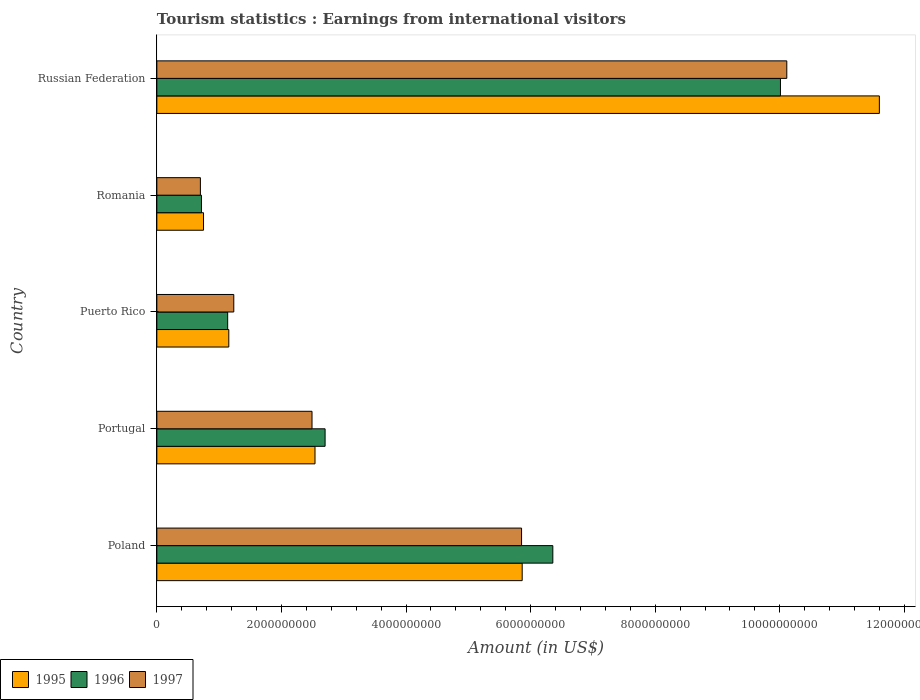How many different coloured bars are there?
Ensure brevity in your answer.  3. How many groups of bars are there?
Offer a terse response. 5. Are the number of bars on each tick of the Y-axis equal?
Ensure brevity in your answer.  Yes. How many bars are there on the 3rd tick from the top?
Provide a short and direct response. 3. How many bars are there on the 4th tick from the bottom?
Make the answer very short. 3. What is the label of the 2nd group of bars from the top?
Provide a succinct answer. Romania. In how many cases, is the number of bars for a given country not equal to the number of legend labels?
Offer a very short reply. 0. What is the earnings from international visitors in 1995 in Romania?
Provide a short and direct response. 7.49e+08. Across all countries, what is the maximum earnings from international visitors in 1996?
Keep it short and to the point. 1.00e+1. Across all countries, what is the minimum earnings from international visitors in 1995?
Provide a short and direct response. 7.49e+08. In which country was the earnings from international visitors in 1996 maximum?
Ensure brevity in your answer.  Russian Federation. In which country was the earnings from international visitors in 1995 minimum?
Your answer should be compact. Romania. What is the total earnings from international visitors in 1995 in the graph?
Your answer should be very brief. 2.19e+1. What is the difference between the earnings from international visitors in 1997 in Poland and that in Puerto Rico?
Provide a succinct answer. 4.62e+09. What is the difference between the earnings from international visitors in 1995 in Romania and the earnings from international visitors in 1997 in Puerto Rico?
Provide a succinct answer. -4.86e+08. What is the average earnings from international visitors in 1995 per country?
Make the answer very short. 4.38e+09. What is the difference between the earnings from international visitors in 1995 and earnings from international visitors in 1996 in Russian Federation?
Provide a short and direct response. 1.59e+09. What is the ratio of the earnings from international visitors in 1996 in Romania to that in Russian Federation?
Your answer should be very brief. 0.07. What is the difference between the highest and the second highest earnings from international visitors in 1997?
Your answer should be compact. 4.26e+09. What is the difference between the highest and the lowest earnings from international visitors in 1995?
Offer a terse response. 1.08e+1. What does the 1st bar from the bottom in Portugal represents?
Provide a succinct answer. 1995. How many countries are there in the graph?
Provide a succinct answer. 5. How are the legend labels stacked?
Make the answer very short. Horizontal. What is the title of the graph?
Provide a short and direct response. Tourism statistics : Earnings from international visitors. Does "2005" appear as one of the legend labels in the graph?
Your response must be concise. No. What is the label or title of the X-axis?
Give a very brief answer. Amount (in US$). What is the Amount (in US$) of 1995 in Poland?
Keep it short and to the point. 5.86e+09. What is the Amount (in US$) in 1996 in Poland?
Provide a succinct answer. 6.36e+09. What is the Amount (in US$) of 1997 in Poland?
Your response must be concise. 5.86e+09. What is the Amount (in US$) in 1995 in Portugal?
Make the answer very short. 2.54e+09. What is the Amount (in US$) of 1996 in Portugal?
Give a very brief answer. 2.70e+09. What is the Amount (in US$) in 1997 in Portugal?
Offer a very short reply. 2.49e+09. What is the Amount (in US$) in 1995 in Puerto Rico?
Your answer should be compact. 1.16e+09. What is the Amount (in US$) of 1996 in Puerto Rico?
Offer a very short reply. 1.14e+09. What is the Amount (in US$) of 1997 in Puerto Rico?
Offer a terse response. 1.24e+09. What is the Amount (in US$) of 1995 in Romania?
Offer a very short reply. 7.49e+08. What is the Amount (in US$) in 1996 in Romania?
Ensure brevity in your answer.  7.16e+08. What is the Amount (in US$) in 1997 in Romania?
Ensure brevity in your answer.  6.99e+08. What is the Amount (in US$) of 1995 in Russian Federation?
Provide a short and direct response. 1.16e+1. What is the Amount (in US$) in 1996 in Russian Federation?
Offer a very short reply. 1.00e+1. What is the Amount (in US$) of 1997 in Russian Federation?
Offer a very short reply. 1.01e+1. Across all countries, what is the maximum Amount (in US$) in 1995?
Make the answer very short. 1.16e+1. Across all countries, what is the maximum Amount (in US$) in 1996?
Keep it short and to the point. 1.00e+1. Across all countries, what is the maximum Amount (in US$) of 1997?
Your answer should be very brief. 1.01e+1. Across all countries, what is the minimum Amount (in US$) in 1995?
Offer a terse response. 7.49e+08. Across all countries, what is the minimum Amount (in US$) in 1996?
Offer a very short reply. 7.16e+08. Across all countries, what is the minimum Amount (in US$) of 1997?
Provide a succinct answer. 6.99e+08. What is the total Amount (in US$) in 1995 in the graph?
Your answer should be very brief. 2.19e+1. What is the total Amount (in US$) of 1996 in the graph?
Your answer should be compact. 2.09e+1. What is the total Amount (in US$) in 1997 in the graph?
Ensure brevity in your answer.  2.04e+1. What is the difference between the Amount (in US$) in 1995 in Poland and that in Portugal?
Ensure brevity in your answer.  3.33e+09. What is the difference between the Amount (in US$) in 1996 in Poland and that in Portugal?
Offer a terse response. 3.66e+09. What is the difference between the Amount (in US$) of 1997 in Poland and that in Portugal?
Offer a very short reply. 3.36e+09. What is the difference between the Amount (in US$) of 1995 in Poland and that in Puerto Rico?
Provide a short and direct response. 4.71e+09. What is the difference between the Amount (in US$) in 1996 in Poland and that in Puerto Rico?
Offer a terse response. 5.22e+09. What is the difference between the Amount (in US$) in 1997 in Poland and that in Puerto Rico?
Provide a short and direct response. 4.62e+09. What is the difference between the Amount (in US$) of 1995 in Poland and that in Romania?
Ensure brevity in your answer.  5.12e+09. What is the difference between the Amount (in US$) of 1996 in Poland and that in Romania?
Your response must be concise. 5.64e+09. What is the difference between the Amount (in US$) of 1997 in Poland and that in Romania?
Ensure brevity in your answer.  5.16e+09. What is the difference between the Amount (in US$) of 1995 in Poland and that in Russian Federation?
Ensure brevity in your answer.  -5.73e+09. What is the difference between the Amount (in US$) of 1996 in Poland and that in Russian Federation?
Your response must be concise. -3.65e+09. What is the difference between the Amount (in US$) of 1997 in Poland and that in Russian Federation?
Your answer should be compact. -4.26e+09. What is the difference between the Amount (in US$) in 1995 in Portugal and that in Puerto Rico?
Offer a terse response. 1.38e+09. What is the difference between the Amount (in US$) of 1996 in Portugal and that in Puerto Rico?
Make the answer very short. 1.56e+09. What is the difference between the Amount (in US$) of 1997 in Portugal and that in Puerto Rico?
Ensure brevity in your answer.  1.26e+09. What is the difference between the Amount (in US$) of 1995 in Portugal and that in Romania?
Ensure brevity in your answer.  1.79e+09. What is the difference between the Amount (in US$) in 1996 in Portugal and that in Romania?
Provide a succinct answer. 1.98e+09. What is the difference between the Amount (in US$) in 1997 in Portugal and that in Romania?
Provide a short and direct response. 1.79e+09. What is the difference between the Amount (in US$) in 1995 in Portugal and that in Russian Federation?
Your answer should be compact. -9.06e+09. What is the difference between the Amount (in US$) in 1996 in Portugal and that in Russian Federation?
Offer a terse response. -7.31e+09. What is the difference between the Amount (in US$) in 1997 in Portugal and that in Russian Federation?
Provide a succinct answer. -7.62e+09. What is the difference between the Amount (in US$) of 1995 in Puerto Rico and that in Romania?
Give a very brief answer. 4.06e+08. What is the difference between the Amount (in US$) in 1996 in Puerto Rico and that in Romania?
Keep it short and to the point. 4.21e+08. What is the difference between the Amount (in US$) in 1997 in Puerto Rico and that in Romania?
Provide a succinct answer. 5.36e+08. What is the difference between the Amount (in US$) in 1995 in Puerto Rico and that in Russian Federation?
Your response must be concise. -1.04e+1. What is the difference between the Amount (in US$) of 1996 in Puerto Rico and that in Russian Federation?
Offer a terse response. -8.87e+09. What is the difference between the Amount (in US$) in 1997 in Puerto Rico and that in Russian Federation?
Your response must be concise. -8.88e+09. What is the difference between the Amount (in US$) in 1995 in Romania and that in Russian Federation?
Give a very brief answer. -1.08e+1. What is the difference between the Amount (in US$) of 1996 in Romania and that in Russian Federation?
Provide a succinct answer. -9.30e+09. What is the difference between the Amount (in US$) in 1997 in Romania and that in Russian Federation?
Your response must be concise. -9.41e+09. What is the difference between the Amount (in US$) of 1995 in Poland and the Amount (in US$) of 1996 in Portugal?
Make the answer very short. 3.16e+09. What is the difference between the Amount (in US$) in 1995 in Poland and the Amount (in US$) in 1997 in Portugal?
Give a very brief answer. 3.37e+09. What is the difference between the Amount (in US$) in 1996 in Poland and the Amount (in US$) in 1997 in Portugal?
Your answer should be very brief. 3.87e+09. What is the difference between the Amount (in US$) in 1995 in Poland and the Amount (in US$) in 1996 in Puerto Rico?
Provide a succinct answer. 4.73e+09. What is the difference between the Amount (in US$) of 1995 in Poland and the Amount (in US$) of 1997 in Puerto Rico?
Provide a succinct answer. 4.63e+09. What is the difference between the Amount (in US$) in 1996 in Poland and the Amount (in US$) in 1997 in Puerto Rico?
Give a very brief answer. 5.12e+09. What is the difference between the Amount (in US$) in 1995 in Poland and the Amount (in US$) in 1996 in Romania?
Provide a succinct answer. 5.15e+09. What is the difference between the Amount (in US$) of 1995 in Poland and the Amount (in US$) of 1997 in Romania?
Ensure brevity in your answer.  5.17e+09. What is the difference between the Amount (in US$) of 1996 in Poland and the Amount (in US$) of 1997 in Romania?
Offer a very short reply. 5.66e+09. What is the difference between the Amount (in US$) in 1995 in Poland and the Amount (in US$) in 1996 in Russian Federation?
Ensure brevity in your answer.  -4.15e+09. What is the difference between the Amount (in US$) of 1995 in Poland and the Amount (in US$) of 1997 in Russian Federation?
Your response must be concise. -4.25e+09. What is the difference between the Amount (in US$) of 1996 in Poland and the Amount (in US$) of 1997 in Russian Federation?
Your answer should be very brief. -3.76e+09. What is the difference between the Amount (in US$) of 1995 in Portugal and the Amount (in US$) of 1996 in Puerto Rico?
Provide a short and direct response. 1.40e+09. What is the difference between the Amount (in US$) of 1995 in Portugal and the Amount (in US$) of 1997 in Puerto Rico?
Give a very brief answer. 1.30e+09. What is the difference between the Amount (in US$) of 1996 in Portugal and the Amount (in US$) of 1997 in Puerto Rico?
Ensure brevity in your answer.  1.47e+09. What is the difference between the Amount (in US$) in 1995 in Portugal and the Amount (in US$) in 1996 in Romania?
Make the answer very short. 1.82e+09. What is the difference between the Amount (in US$) in 1995 in Portugal and the Amount (in US$) in 1997 in Romania?
Your response must be concise. 1.84e+09. What is the difference between the Amount (in US$) of 1996 in Portugal and the Amount (in US$) of 1997 in Romania?
Your answer should be very brief. 2.00e+09. What is the difference between the Amount (in US$) in 1995 in Portugal and the Amount (in US$) in 1996 in Russian Federation?
Your answer should be very brief. -7.47e+09. What is the difference between the Amount (in US$) in 1995 in Portugal and the Amount (in US$) in 1997 in Russian Federation?
Make the answer very short. -7.57e+09. What is the difference between the Amount (in US$) in 1996 in Portugal and the Amount (in US$) in 1997 in Russian Federation?
Provide a short and direct response. -7.41e+09. What is the difference between the Amount (in US$) in 1995 in Puerto Rico and the Amount (in US$) in 1996 in Romania?
Provide a short and direct response. 4.39e+08. What is the difference between the Amount (in US$) in 1995 in Puerto Rico and the Amount (in US$) in 1997 in Romania?
Provide a succinct answer. 4.56e+08. What is the difference between the Amount (in US$) of 1996 in Puerto Rico and the Amount (in US$) of 1997 in Romania?
Make the answer very short. 4.38e+08. What is the difference between the Amount (in US$) in 1995 in Puerto Rico and the Amount (in US$) in 1996 in Russian Federation?
Provide a succinct answer. -8.86e+09. What is the difference between the Amount (in US$) of 1995 in Puerto Rico and the Amount (in US$) of 1997 in Russian Federation?
Make the answer very short. -8.96e+09. What is the difference between the Amount (in US$) in 1996 in Puerto Rico and the Amount (in US$) in 1997 in Russian Federation?
Keep it short and to the point. -8.98e+09. What is the difference between the Amount (in US$) in 1995 in Romania and the Amount (in US$) in 1996 in Russian Federation?
Your response must be concise. -9.26e+09. What is the difference between the Amount (in US$) in 1995 in Romania and the Amount (in US$) in 1997 in Russian Federation?
Keep it short and to the point. -9.36e+09. What is the difference between the Amount (in US$) of 1996 in Romania and the Amount (in US$) of 1997 in Russian Federation?
Provide a short and direct response. -9.40e+09. What is the average Amount (in US$) in 1995 per country?
Ensure brevity in your answer.  4.38e+09. What is the average Amount (in US$) of 1996 per country?
Provide a short and direct response. 4.18e+09. What is the average Amount (in US$) of 1997 per country?
Provide a short and direct response. 4.08e+09. What is the difference between the Amount (in US$) in 1995 and Amount (in US$) in 1996 in Poland?
Your answer should be compact. -4.92e+08. What is the difference between the Amount (in US$) in 1995 and Amount (in US$) in 1997 in Poland?
Your answer should be compact. 1.00e+07. What is the difference between the Amount (in US$) in 1996 and Amount (in US$) in 1997 in Poland?
Provide a succinct answer. 5.02e+08. What is the difference between the Amount (in US$) in 1995 and Amount (in US$) in 1996 in Portugal?
Make the answer very short. -1.62e+08. What is the difference between the Amount (in US$) of 1995 and Amount (in US$) of 1997 in Portugal?
Give a very brief answer. 4.80e+07. What is the difference between the Amount (in US$) of 1996 and Amount (in US$) of 1997 in Portugal?
Offer a terse response. 2.10e+08. What is the difference between the Amount (in US$) of 1995 and Amount (in US$) of 1996 in Puerto Rico?
Your answer should be compact. 1.80e+07. What is the difference between the Amount (in US$) of 1995 and Amount (in US$) of 1997 in Puerto Rico?
Ensure brevity in your answer.  -8.00e+07. What is the difference between the Amount (in US$) of 1996 and Amount (in US$) of 1997 in Puerto Rico?
Keep it short and to the point. -9.80e+07. What is the difference between the Amount (in US$) in 1995 and Amount (in US$) in 1996 in Romania?
Your response must be concise. 3.30e+07. What is the difference between the Amount (in US$) of 1996 and Amount (in US$) of 1997 in Romania?
Offer a terse response. 1.70e+07. What is the difference between the Amount (in US$) in 1995 and Amount (in US$) in 1996 in Russian Federation?
Provide a short and direct response. 1.59e+09. What is the difference between the Amount (in US$) of 1995 and Amount (in US$) of 1997 in Russian Federation?
Make the answer very short. 1.49e+09. What is the difference between the Amount (in US$) in 1996 and Amount (in US$) in 1997 in Russian Federation?
Ensure brevity in your answer.  -1.02e+08. What is the ratio of the Amount (in US$) of 1995 in Poland to that in Portugal?
Provide a succinct answer. 2.31. What is the ratio of the Amount (in US$) of 1996 in Poland to that in Portugal?
Your answer should be compact. 2.35. What is the ratio of the Amount (in US$) of 1997 in Poland to that in Portugal?
Provide a succinct answer. 2.35. What is the ratio of the Amount (in US$) in 1995 in Poland to that in Puerto Rico?
Ensure brevity in your answer.  5.08. What is the ratio of the Amount (in US$) of 1996 in Poland to that in Puerto Rico?
Offer a very short reply. 5.59. What is the ratio of the Amount (in US$) in 1997 in Poland to that in Puerto Rico?
Give a very brief answer. 4.74. What is the ratio of the Amount (in US$) in 1995 in Poland to that in Romania?
Provide a short and direct response. 7.83. What is the ratio of the Amount (in US$) of 1996 in Poland to that in Romania?
Give a very brief answer. 8.88. What is the ratio of the Amount (in US$) of 1997 in Poland to that in Romania?
Provide a short and direct response. 8.38. What is the ratio of the Amount (in US$) of 1995 in Poland to that in Russian Federation?
Ensure brevity in your answer.  0.51. What is the ratio of the Amount (in US$) in 1996 in Poland to that in Russian Federation?
Ensure brevity in your answer.  0.64. What is the ratio of the Amount (in US$) in 1997 in Poland to that in Russian Federation?
Make the answer very short. 0.58. What is the ratio of the Amount (in US$) in 1995 in Portugal to that in Puerto Rico?
Provide a short and direct response. 2.2. What is the ratio of the Amount (in US$) in 1996 in Portugal to that in Puerto Rico?
Offer a terse response. 2.38. What is the ratio of the Amount (in US$) in 1997 in Portugal to that in Puerto Rico?
Give a very brief answer. 2.02. What is the ratio of the Amount (in US$) of 1995 in Portugal to that in Romania?
Your answer should be very brief. 3.39. What is the ratio of the Amount (in US$) in 1996 in Portugal to that in Romania?
Your answer should be very brief. 3.77. What is the ratio of the Amount (in US$) of 1997 in Portugal to that in Romania?
Your response must be concise. 3.56. What is the ratio of the Amount (in US$) of 1995 in Portugal to that in Russian Federation?
Offer a very short reply. 0.22. What is the ratio of the Amount (in US$) in 1996 in Portugal to that in Russian Federation?
Ensure brevity in your answer.  0.27. What is the ratio of the Amount (in US$) in 1997 in Portugal to that in Russian Federation?
Your answer should be very brief. 0.25. What is the ratio of the Amount (in US$) in 1995 in Puerto Rico to that in Romania?
Your response must be concise. 1.54. What is the ratio of the Amount (in US$) in 1996 in Puerto Rico to that in Romania?
Your answer should be compact. 1.59. What is the ratio of the Amount (in US$) of 1997 in Puerto Rico to that in Romania?
Your answer should be compact. 1.77. What is the ratio of the Amount (in US$) of 1995 in Puerto Rico to that in Russian Federation?
Offer a very short reply. 0.1. What is the ratio of the Amount (in US$) in 1996 in Puerto Rico to that in Russian Federation?
Your answer should be compact. 0.11. What is the ratio of the Amount (in US$) of 1997 in Puerto Rico to that in Russian Federation?
Your response must be concise. 0.12. What is the ratio of the Amount (in US$) of 1995 in Romania to that in Russian Federation?
Offer a very short reply. 0.06. What is the ratio of the Amount (in US$) of 1996 in Romania to that in Russian Federation?
Offer a terse response. 0.07. What is the ratio of the Amount (in US$) of 1997 in Romania to that in Russian Federation?
Provide a short and direct response. 0.07. What is the difference between the highest and the second highest Amount (in US$) of 1995?
Your answer should be compact. 5.73e+09. What is the difference between the highest and the second highest Amount (in US$) of 1996?
Provide a short and direct response. 3.65e+09. What is the difference between the highest and the second highest Amount (in US$) in 1997?
Offer a terse response. 4.26e+09. What is the difference between the highest and the lowest Amount (in US$) in 1995?
Ensure brevity in your answer.  1.08e+1. What is the difference between the highest and the lowest Amount (in US$) in 1996?
Your response must be concise. 9.30e+09. What is the difference between the highest and the lowest Amount (in US$) in 1997?
Give a very brief answer. 9.41e+09. 